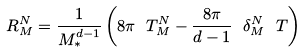<formula> <loc_0><loc_0><loc_500><loc_500>R _ { M } ^ { N } = \frac { 1 } { M _ { \ast } ^ { d - 1 } } \left ( 8 \pi \ T _ { M } ^ { N } - \frac { 8 \pi } { d - 1 } \ \delta _ { M } ^ { N } \ T \right )</formula> 